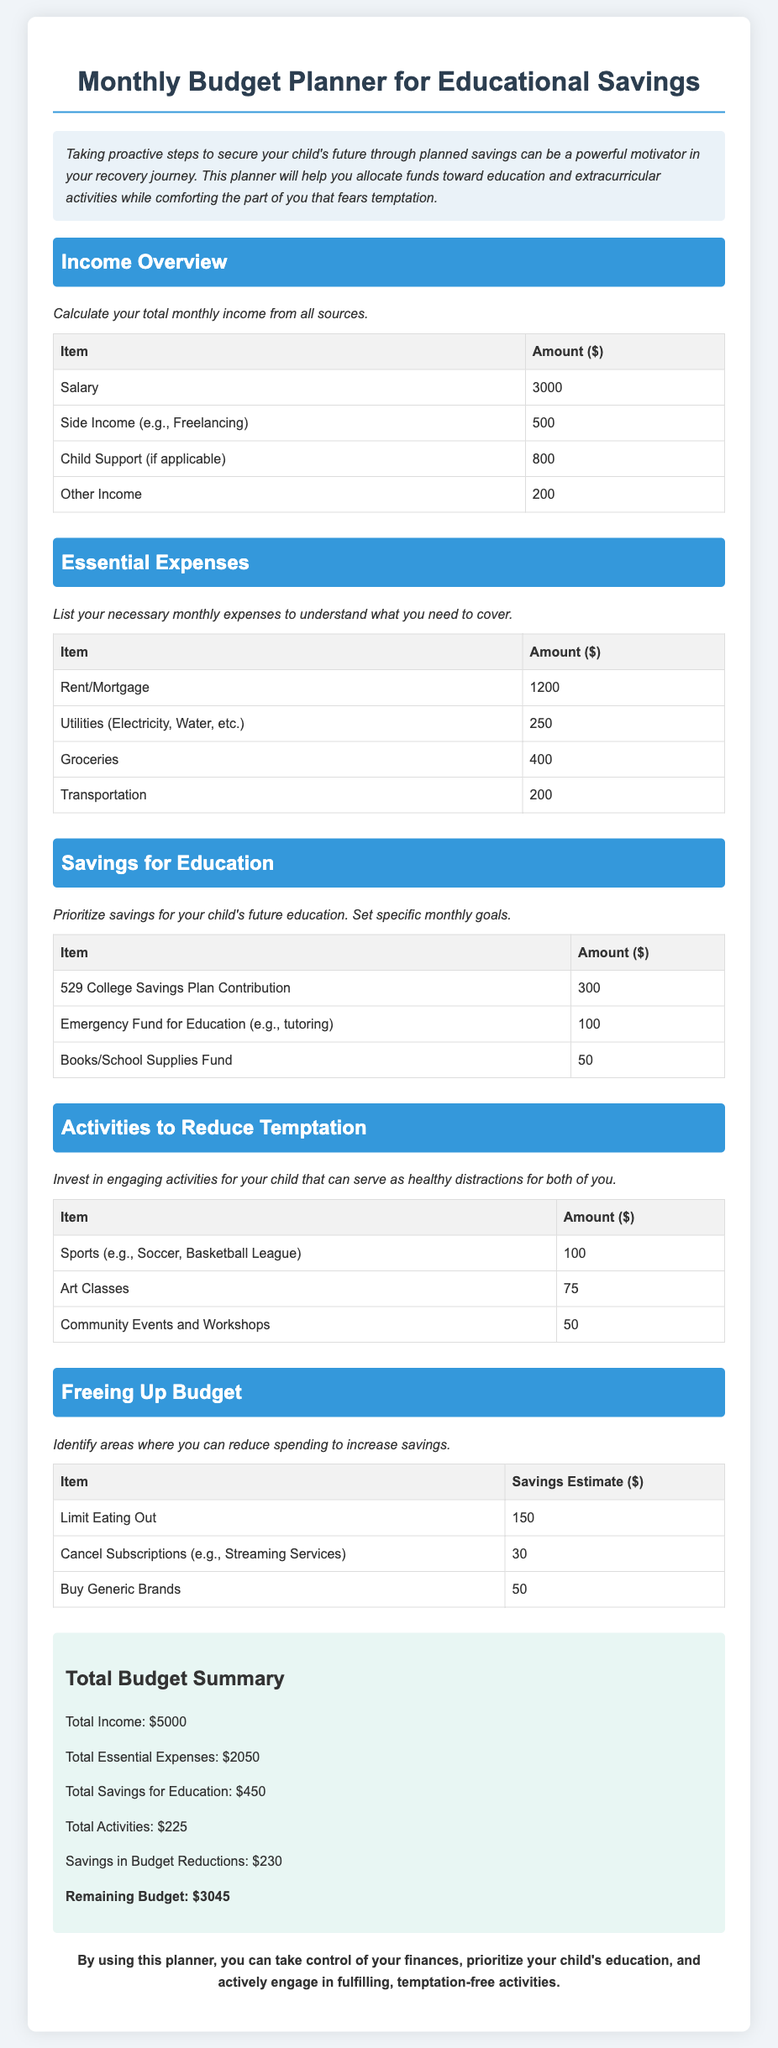What is the total monthly income? The total monthly income is the sum of all income sources in the document, which is 3000 + 500 + 800 + 200 = 5000.
Answer: 5000 What is the amount allocated for the 529 College Savings Plan? The document specifies a monthly contribution amount for the 529 College Savings Plan under the savings for education section, which is $300.
Answer: 300 What are the total essential expenses? The total essential expenses are calculated by summing all listed expenses, which amounts to 1200 + 250 + 400 + 200 = 2050.
Answer: 2050 How much is allocated for community events and workshops? The table in the "Activities to Reduce Temptation" section shows the amount allocated for community events and workshops, which is $50.
Answer: 50 What is the total estimated savings from budget reductions? The total estimated savings from the budget reductions section is the total saveable amounts, calculated as 150 + 30 + 50 = 230.
Answer: 230 What amount is budgeted for sports activities? In the activities section, the budget allocated for sports such as soccer or basketball is mentioned, which is $100.
Answer: 100 What is the remaining budget after all allocations? The remaining budget is extracted from the summary, calculated as Total Income - Total Essential Expenses - Total Savings for Education - Total Activities - Savings in Budget Reductions = 5000 - 2050 - 450 - 225 - 230 = 3045.
Answer: 3045 How much is budgeted for books and school supplies? The document specifies an amount for books and school supplies under the savings for education section, which is $50.
Answer: 50 What percentage of income is directed towards educational savings? The percentage directed towards educational savings can be determined by dividing the total savings for education by total income: (450 / 5000) * 100, resulting in 9%.
Answer: 9% 